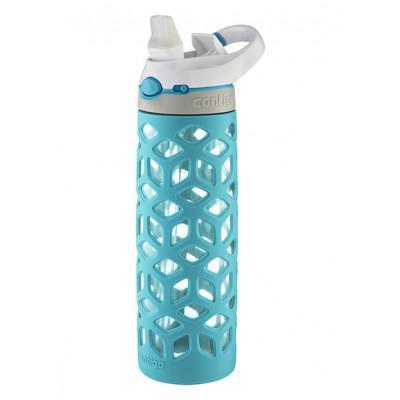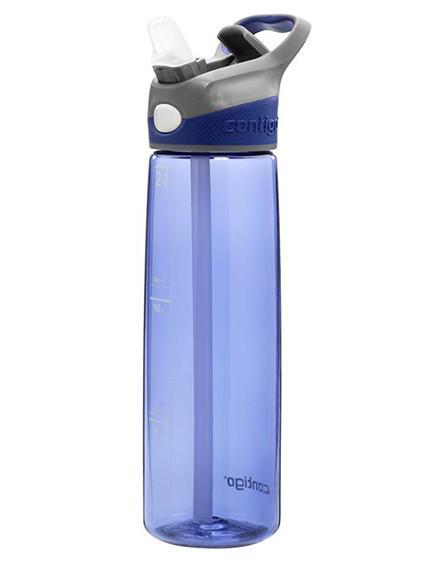The first image is the image on the left, the second image is the image on the right. For the images shown, is this caption "At least one of the bottles in the image is pink." true? Answer yes or no. No. 